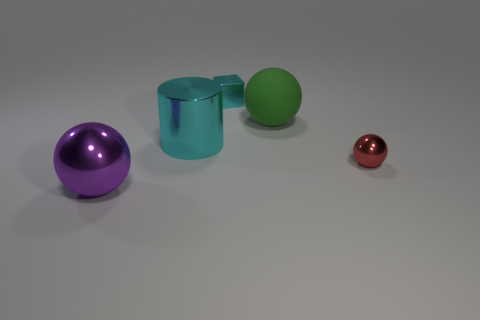Subtract all matte spheres. How many spheres are left? 2 Subtract all cyan spheres. Subtract all red cylinders. How many spheres are left? 3 Subtract all cylinders. How many objects are left? 4 Add 3 tiny blocks. How many objects exist? 8 Add 4 shiny cylinders. How many shiny cylinders exist? 5 Subtract 0 purple blocks. How many objects are left? 5 Subtract all green objects. Subtract all large spheres. How many objects are left? 2 Add 4 matte things. How many matte things are left? 5 